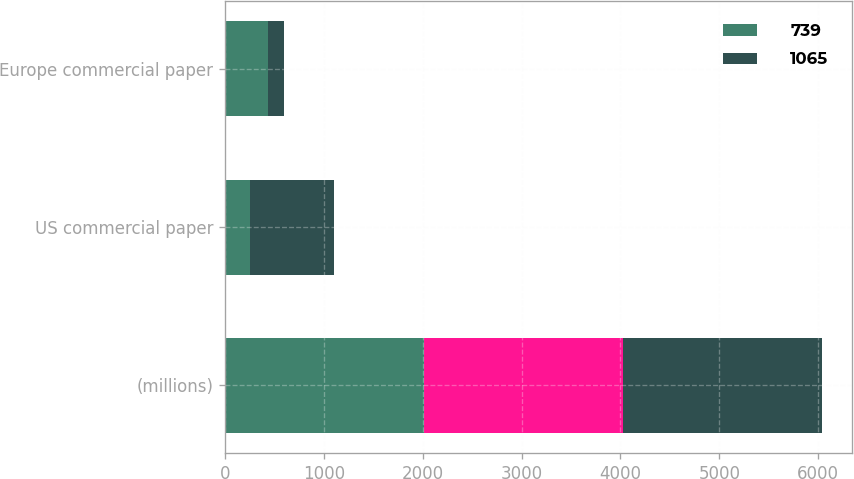Convert chart. <chart><loc_0><loc_0><loc_500><loc_500><stacked_bar_chart><ecel><fcel>(millions)<fcel>US commercial paper<fcel>Europe commercial paper<nl><fcel>739<fcel>2013<fcel>249<fcel>437<nl><fcel>nan<fcel>2013<fcel>0.22<fcel>0.23<nl><fcel>1065<fcel>2012<fcel>853<fcel>159<nl></chart> 